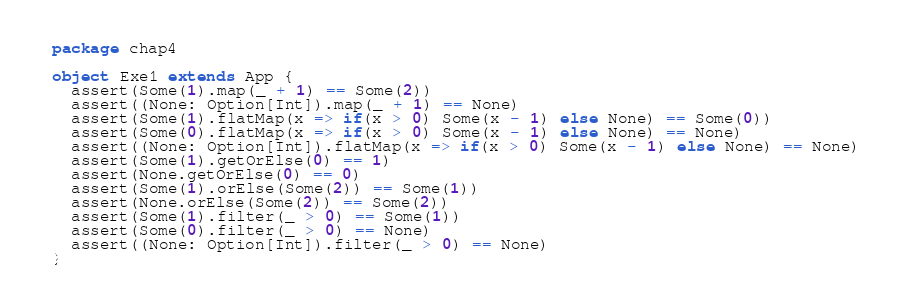<code> <loc_0><loc_0><loc_500><loc_500><_Scala_>package chap4

object Exe1 extends App {
  assert(Some(1).map(_ + 1) == Some(2))
  assert((None: Option[Int]).map(_ + 1) == None)
  assert(Some(1).flatMap(x => if(x > 0) Some(x - 1) else None) == Some(0))
  assert(Some(0).flatMap(x => if(x > 0) Some(x - 1) else None) == None)
  assert((None: Option[Int]).flatMap(x => if(x > 0) Some(x - 1) else None) == None)
  assert(Some(1).getOrElse(0) == 1)
  assert(None.getOrElse(0) == 0)
  assert(Some(1).orElse(Some(2)) == Some(1))
  assert(None.orElse(Some(2)) == Some(2))
  assert(Some(1).filter(_ > 0) == Some(1))
  assert(Some(0).filter(_ > 0) == None)
  assert((None: Option[Int]).filter(_ > 0) == None)
}
</code> 